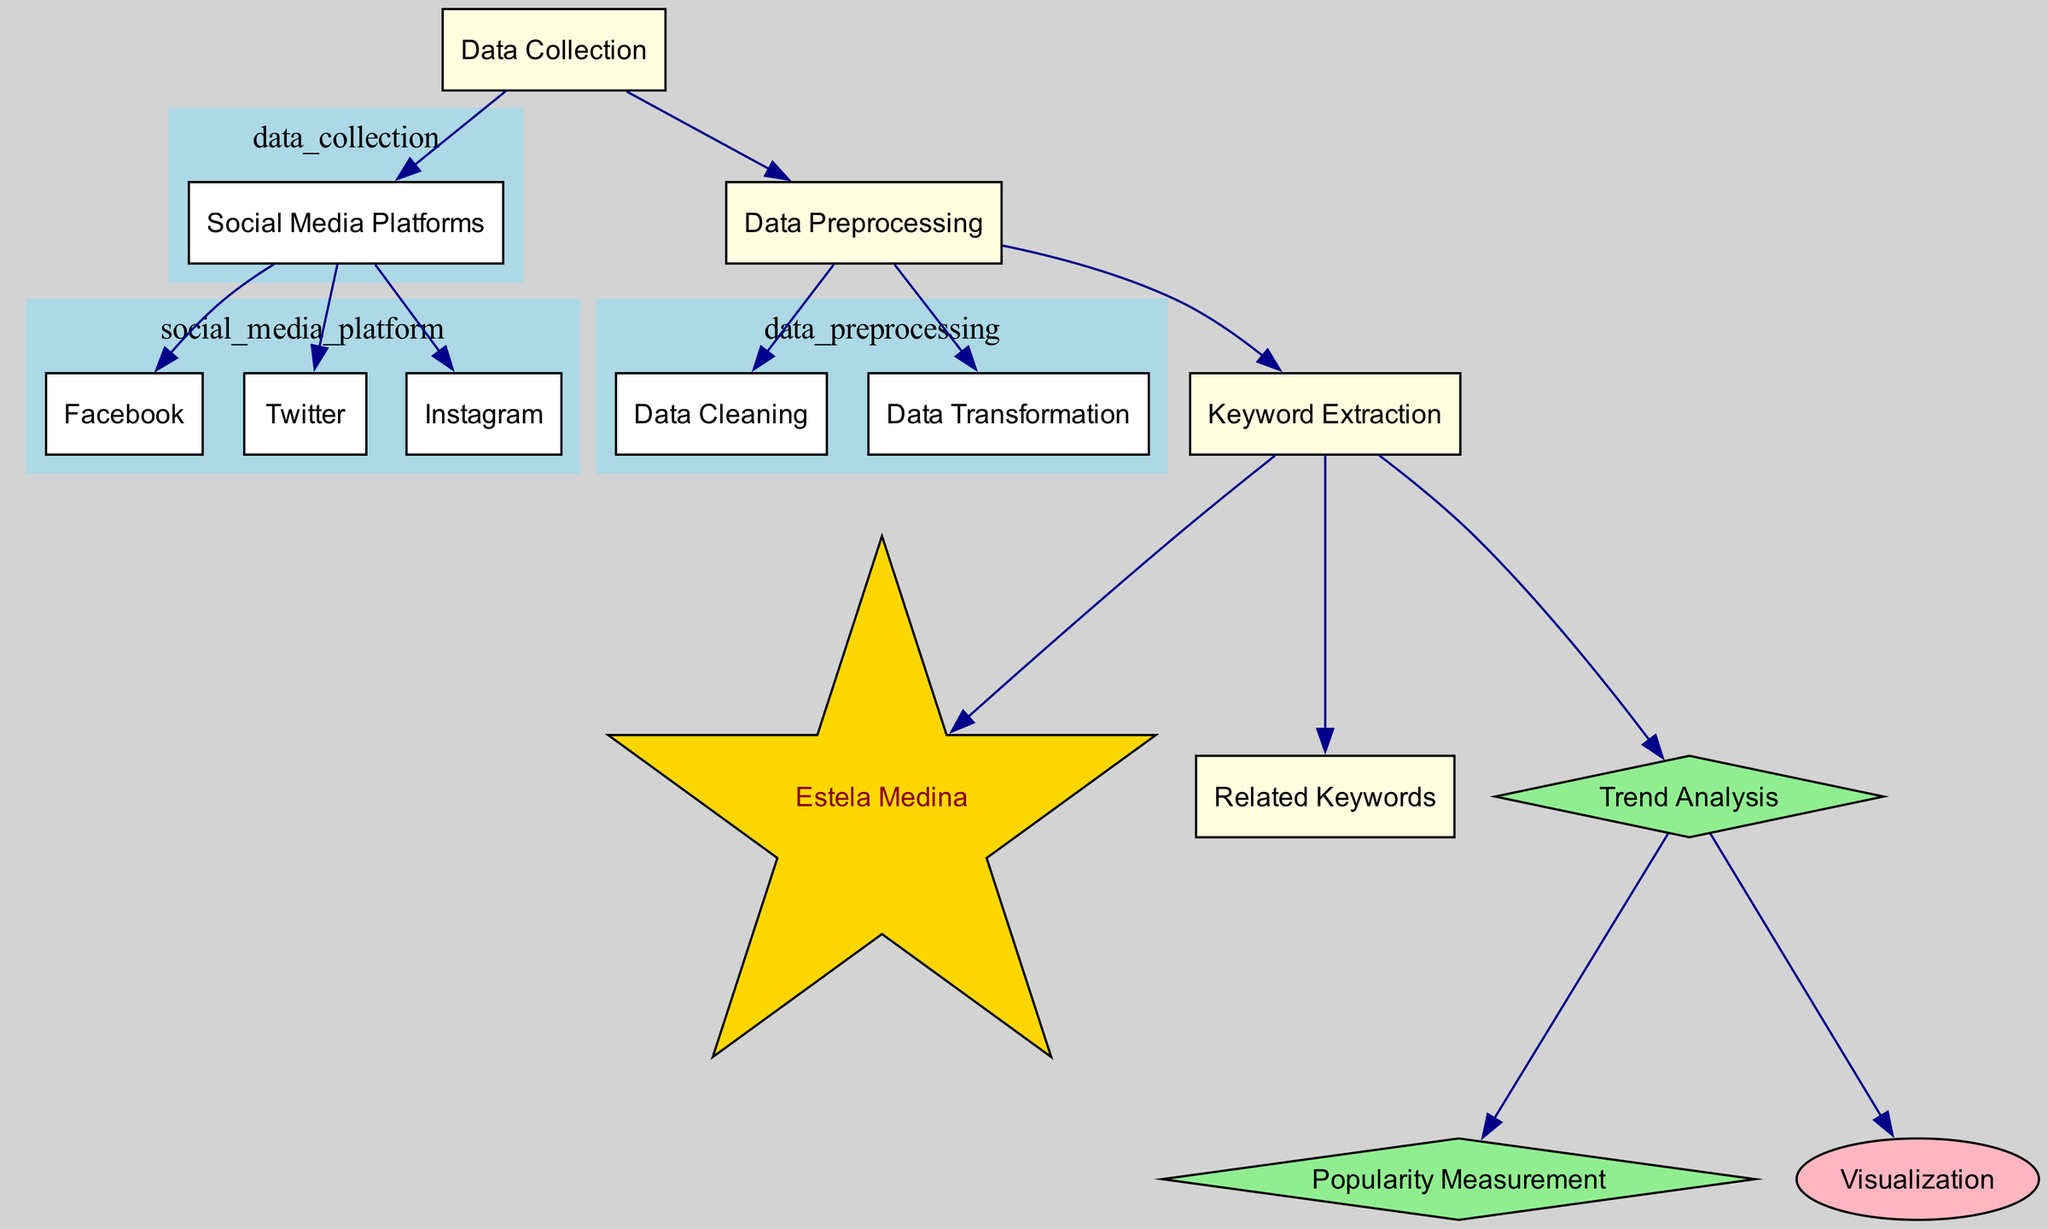What are the parents of the node 'keyword_extraction'? The node 'keyword_extraction' has three parent nodes: 'data_preprocessing', which it is directly connected to, indicating that it is a step that follows data preparation, as well as 'estela_medina' and 'related_keywords' which are extracted as part of its function.
Answer: data_preprocessing How many social media platforms are represented in the diagram? The diagram illustrates three social media platforms connected to the 'data_collection' node: Facebook, Twitter, and Instagram. This count is obtained by simply viewing the connections to the 'social_media_platform' node.
Answer: three Which type of node is 'Estela Medina'? In the diagram, 'Estela Medina' is represented as a star-shaped node, indicating its significance compared to other nodes, which are typically rectangular. This type of shape usually highlights its importance in the context of the analysis.
Answer: star What is the final node connected to 'trend_analysis'? The 'trend_analysis' node is connected to two final nodes: 'popularity_measurement' and 'visualization'. The presence of these connections indicates that after analyzing trends, there are actions taken to measure popularity and visualize the data.
Answer: popularity measurement and visualization What process follows 'data_collection' in the diagram? Following 'data_collection', the next process is 'data_preprocessing', which includes steps like cleaning, transformation, and keyword extraction. The step is crucial for preparing data for further analysis.
Answer: data preprocessing How many nodes are related to 'popular_measurement'? The node 'popularity_measurement' is one of two nodes that follow 'trend_analysis'. The other node connected to 'trend_analysis' is 'visualization', indicating only one direct relationship. Therefore, when counting unique connections, the answer is one node.
Answer: one Which node does 'data_cleaning' lead to? 'Data_cleaning' leads to the 'data_transformation' node, which is critical in the preprocessing phase, suggesting that after cleaning the data, it undergoes transformation to make it suitable for later analysis.
Answer: data transformation What is the relationship between 'social_media_platforms' and 'data_collection'? The relationship is that 'social_media_platforms' are categorized under 'data_collection', showing that social media data collection is the overarching process from which specific platforms like Facebook, Twitter, and Instagram are derived.
Answer: categorization 